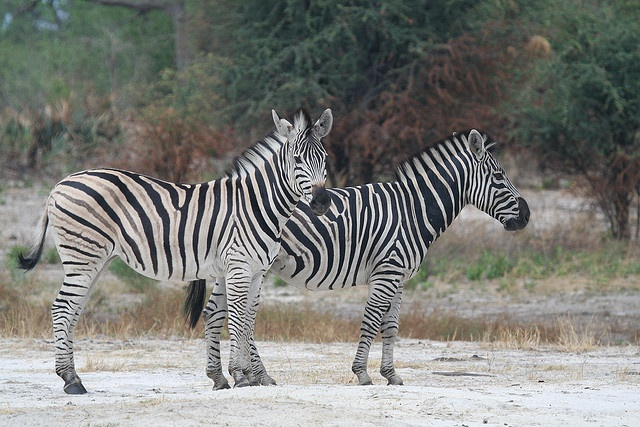Describe the objects in this image and their specific colors. I can see zebra in teal, darkgray, lightgray, black, and gray tones and zebra in teal, black, darkgray, gray, and lightgray tones in this image. 